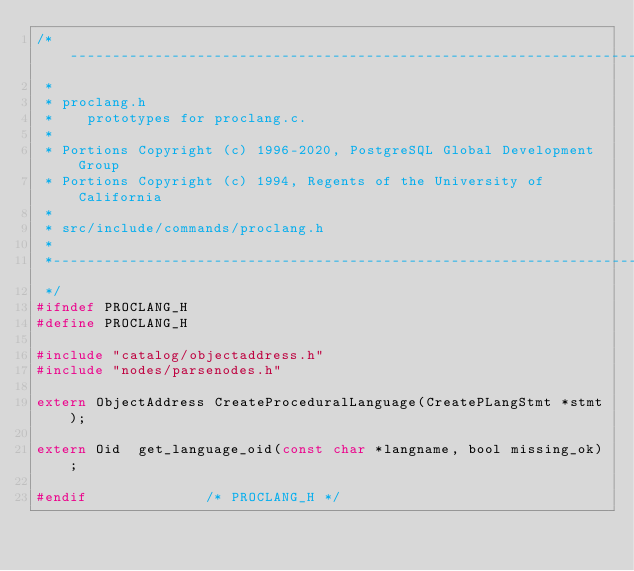Convert code to text. <code><loc_0><loc_0><loc_500><loc_500><_C_>/*-------------------------------------------------------------------------
 *
 * proclang.h
 *	  prototypes for proclang.c.
 *
 * Portions Copyright (c) 1996-2020, PostgreSQL Global Development Group
 * Portions Copyright (c) 1994, Regents of the University of California
 *
 * src/include/commands/proclang.h
 *
 *-------------------------------------------------------------------------
 */
#ifndef PROCLANG_H
#define PROCLANG_H

#include "catalog/objectaddress.h"
#include "nodes/parsenodes.h"

extern ObjectAddress CreateProceduralLanguage(CreatePLangStmt *stmt);

extern Oid	get_language_oid(const char *langname, bool missing_ok);

#endif							/* PROCLANG_H */
</code> 